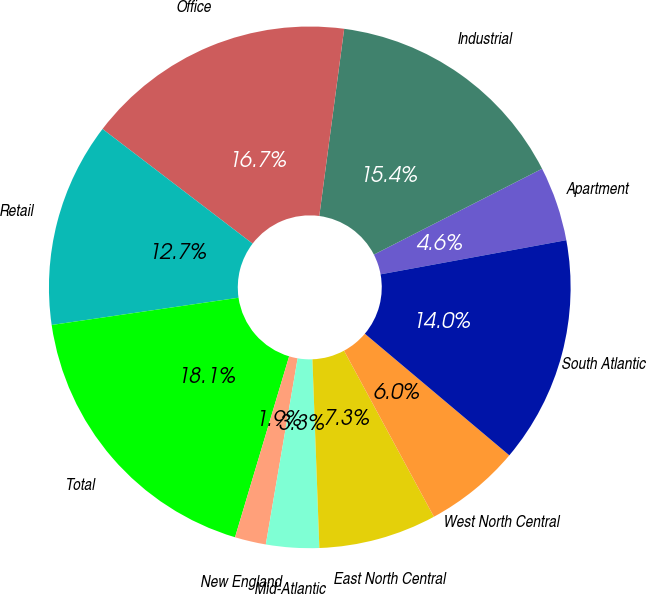Convert chart to OTSL. <chart><loc_0><loc_0><loc_500><loc_500><pie_chart><fcel>Apartment<fcel>Industrial<fcel>Office<fcel>Retail<fcel>Total<fcel>New England<fcel>Mid-Atlantic<fcel>East North Central<fcel>West North Central<fcel>South Atlantic<nl><fcel>4.62%<fcel>15.38%<fcel>16.72%<fcel>12.69%<fcel>18.07%<fcel>1.93%<fcel>3.28%<fcel>7.31%<fcel>5.97%<fcel>14.03%<nl></chart> 